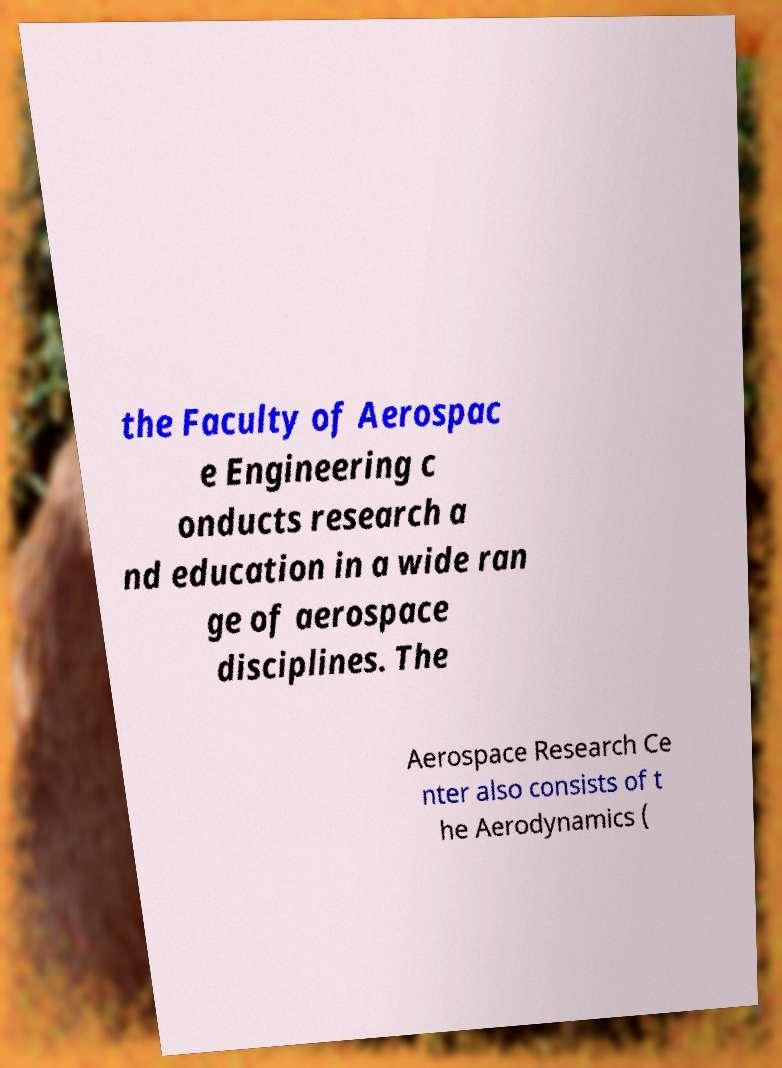Can you read and provide the text displayed in the image?This photo seems to have some interesting text. Can you extract and type it out for me? the Faculty of Aerospac e Engineering c onducts research a nd education in a wide ran ge of aerospace disciplines. The Aerospace Research Ce nter also consists of t he Aerodynamics ( 